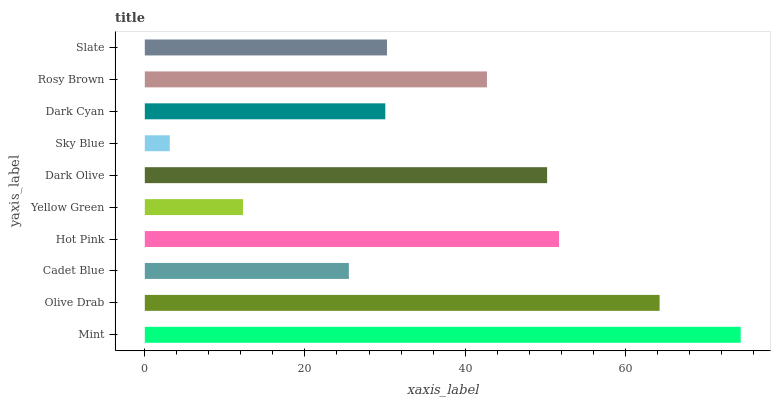Is Sky Blue the minimum?
Answer yes or no. Yes. Is Mint the maximum?
Answer yes or no. Yes. Is Olive Drab the minimum?
Answer yes or no. No. Is Olive Drab the maximum?
Answer yes or no. No. Is Mint greater than Olive Drab?
Answer yes or no. Yes. Is Olive Drab less than Mint?
Answer yes or no. Yes. Is Olive Drab greater than Mint?
Answer yes or no. No. Is Mint less than Olive Drab?
Answer yes or no. No. Is Rosy Brown the high median?
Answer yes or no. Yes. Is Slate the low median?
Answer yes or no. Yes. Is Sky Blue the high median?
Answer yes or no. No. Is Mint the low median?
Answer yes or no. No. 